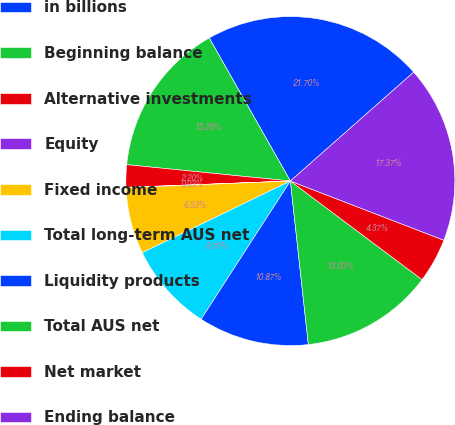<chart> <loc_0><loc_0><loc_500><loc_500><pie_chart><fcel>in billions<fcel>Beginning balance<fcel>Alternative investments<fcel>Equity<fcel>Fixed income<fcel>Total long-term AUS net<fcel>Liquidity products<fcel>Total AUS net<fcel>Net market<fcel>Ending balance<nl><fcel>21.7%<fcel>15.2%<fcel>2.2%<fcel>0.03%<fcel>6.53%<fcel>8.7%<fcel>10.87%<fcel>13.03%<fcel>4.37%<fcel>17.37%<nl></chart> 